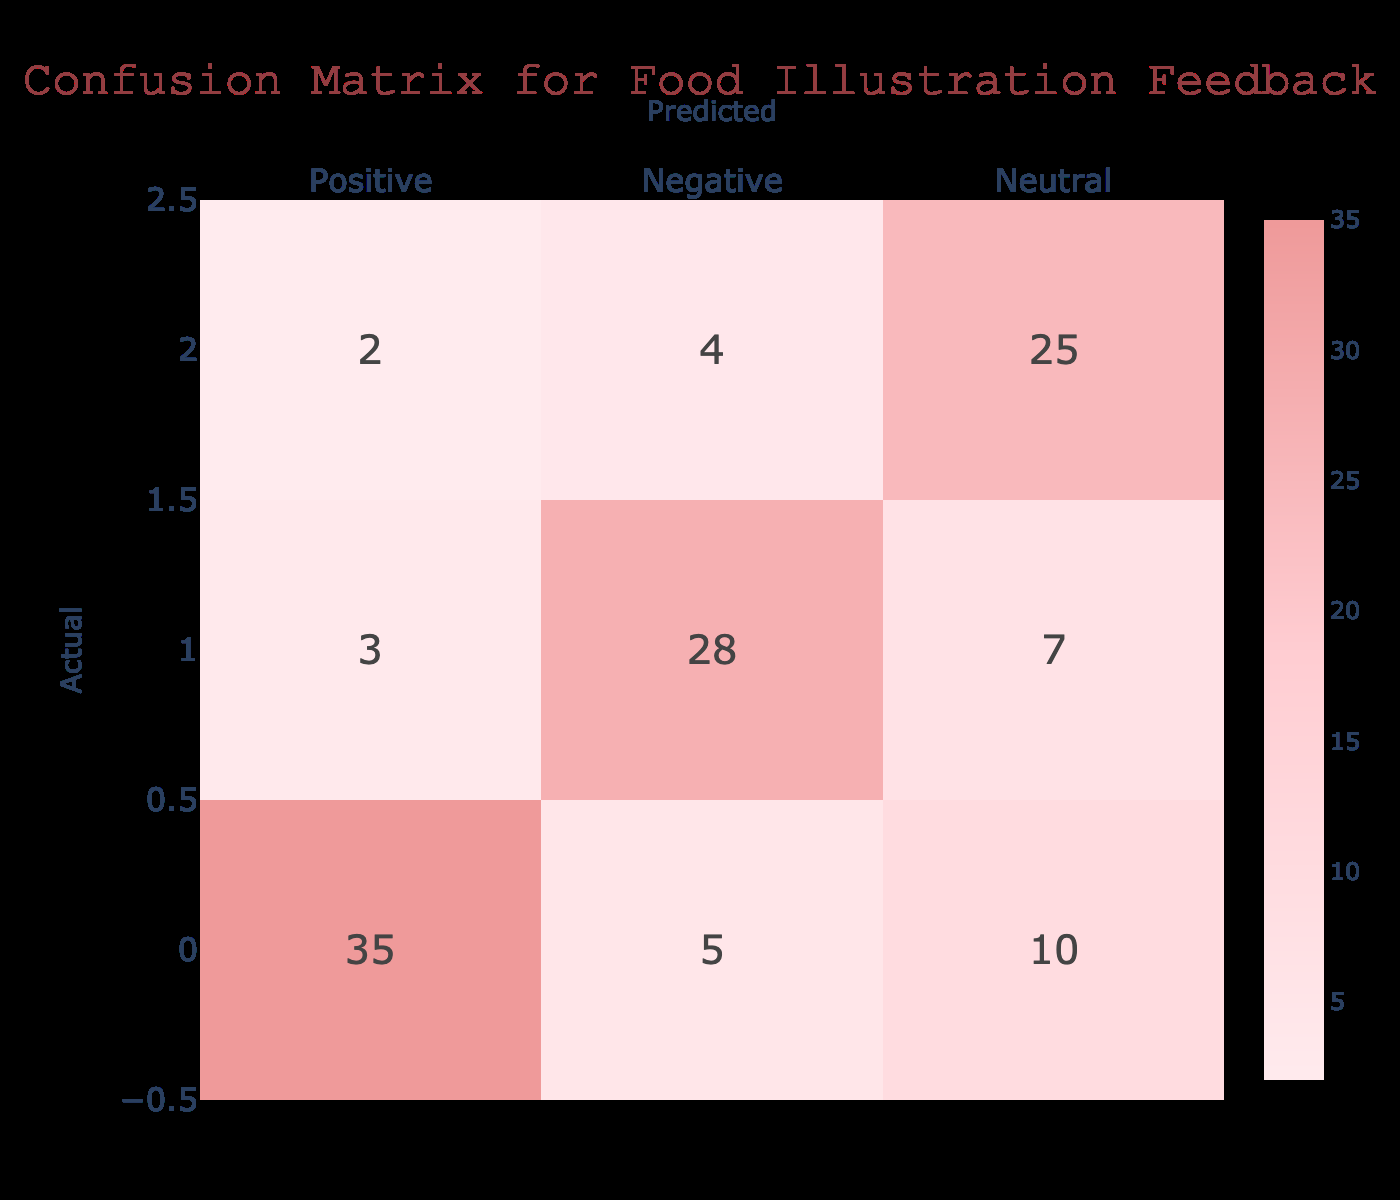What is the total number of feedback responses categorized as Positive? To find the total number of feedback responses categorized as Positive, sum the values in the Positive column: 35 (True Positive) + 5 (False Negative) + 10 (False Neutral) = 50.
Answer: 50 What percentage of the actual Positive feedback was predicted correctly? The correctly predicted Positive feedback (True Positive) is 35. To get the percentage, divide the True Positive by the total actual Positive feedback (which is 35 + 5 + 10 = 50) and multiply by 100: (35 / 50) * 100 = 70%.
Answer: 70% How many Neutral feedback responses were incorrectly classified as Negative? The number of Neutral feedback responses incorrectly classified as Negative is represented by the cell in the Neutral row and Negative column, which is 4.
Answer: 4 Is the number of True Negatives greater than the number of True Positives? True Negatives (28) are the responses predicted as Negative that are actually Negative. True Positives (35) are the responses predicted as Positive that are actually Positive. Since 28 is less than 35, the answer is No.
Answer: No What is the total number of feedback responses? To find the total number of feedback responses, sum all values in the matrix: 35 (TP) + 5 (FN) + 10 (FN) + 3 (FP) + 28 (TN) + 7 (FP) + 2 (FP) + 4 (FN) + 25 (TN) = 115.
Answer: 115 If we consider Neutral as a separate category, how many were not correctly classified? The number of Neutral feedback not correctly classified includes those predicted as Positive (10) and Negative (4), totaling: 10 + 4 = 14.
Answer: 14 What is the proportion of Negative feedback correctly classified? To find the proportion of Negative feedback that was correctly classified (True Negative), divide True Negative (28) by the total actual Negative feedback (3 + 28 + 7 = 38): 28 / 38 ≈ 0.7368 or about 73.68%.
Answer: 73.68% How many responses were predicted as Positive but were actually Neutral? The number of responses predicted as Positive but were actually Neutral is represented by the cell in the Positive row and Neutral column, which is 10.
Answer: 10 If we were to improve prediction accuracy, would it be beneficial to focus on reducing False Negatives or False Positives based on the matrix? Evaluating the False Negative cases (5 for Positive, 2 for Neutral) and False Positives (3 for Negative), focusing on reducing False Negatives could lead to better results since they relate to misclassifying actual Positives.
Answer: Yes 